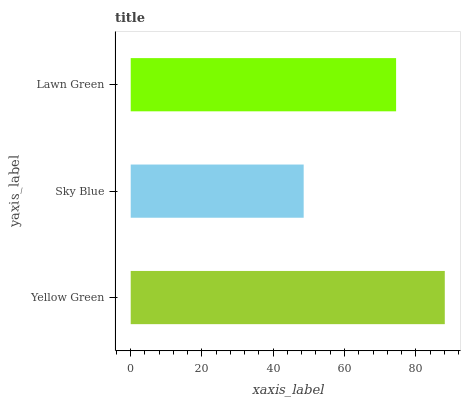Is Sky Blue the minimum?
Answer yes or no. Yes. Is Yellow Green the maximum?
Answer yes or no. Yes. Is Lawn Green the minimum?
Answer yes or no. No. Is Lawn Green the maximum?
Answer yes or no. No. Is Lawn Green greater than Sky Blue?
Answer yes or no. Yes. Is Sky Blue less than Lawn Green?
Answer yes or no. Yes. Is Sky Blue greater than Lawn Green?
Answer yes or no. No. Is Lawn Green less than Sky Blue?
Answer yes or no. No. Is Lawn Green the high median?
Answer yes or no. Yes. Is Lawn Green the low median?
Answer yes or no. Yes. Is Sky Blue the high median?
Answer yes or no. No. Is Yellow Green the low median?
Answer yes or no. No. 